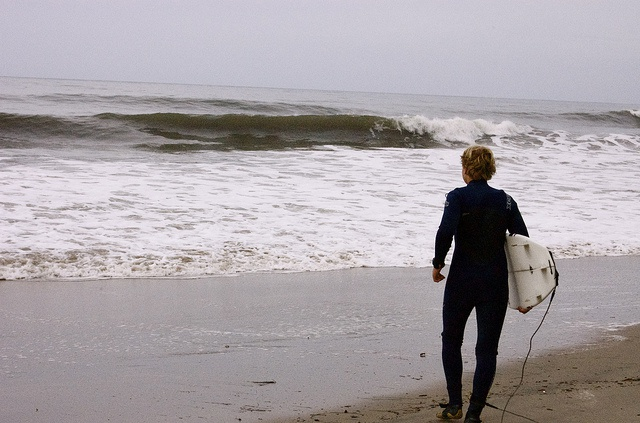Describe the objects in this image and their specific colors. I can see people in lightgray, black, maroon, and gray tones and surfboard in lightgray, darkgray, and gray tones in this image. 